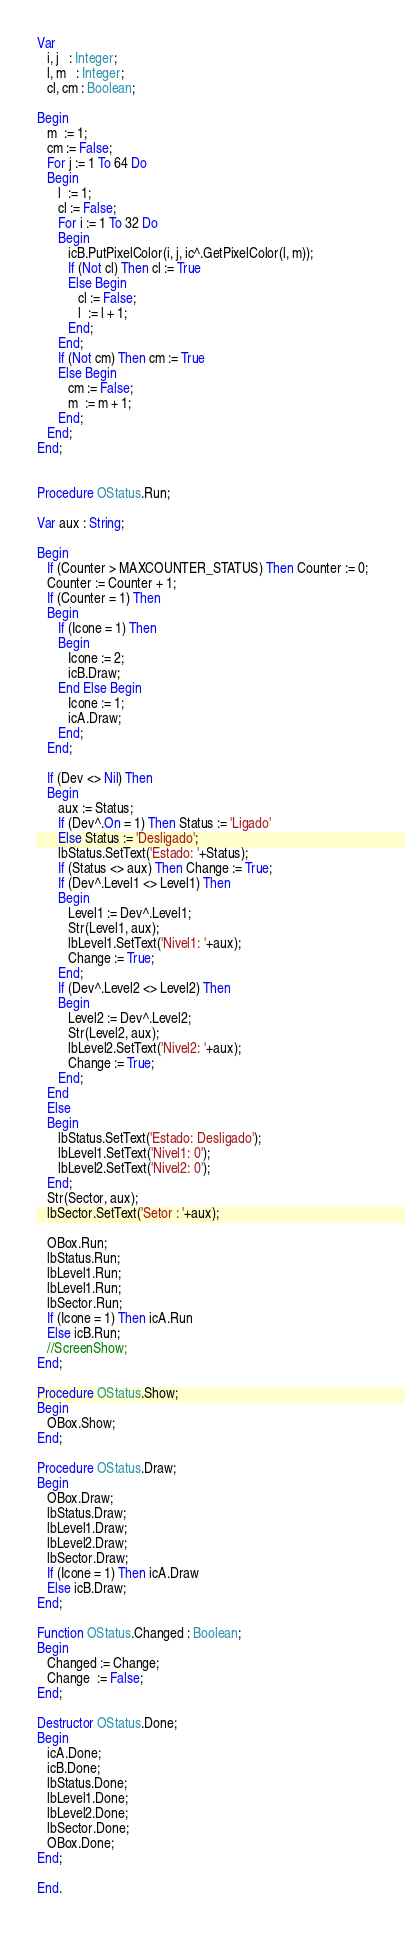<code> <loc_0><loc_0><loc_500><loc_500><_Pascal_>
Var
   i, j   : Integer;
   l, m   : Integer;
   cl, cm : Boolean;

Begin
   m  := 1;
   cm := False;
   For j := 1 To 64 Do
   Begin
      l  := 1;
      cl := False;
      For i := 1 To 32 Do
      Begin
         icB.PutPixelColor(i, j, ic^.GetPixelColor(l, m));
         If (Not cl) Then cl := True
         Else Begin
            cl := False;
            l  := l + 1;
         End;
      End;
      If (Not cm) Then cm := True
      Else Begin
         cm := False;
         m  := m + 1;
      End;
   End;
End;


Procedure OStatus.Run;

Var aux : String;

Begin
   If (Counter > MAXCOUNTER_STATUS) Then Counter := 0;
   Counter := Counter + 1;
   If (Counter = 1) Then
   Begin
      If (Icone = 1) Then
      Begin
         Icone := 2;
         icB.Draw;
      End Else Begin
         Icone := 1;
         icA.Draw;
      End;
   End;

   If (Dev <> Nil) Then
   Begin
      aux := Status;
      If (Dev^.On = 1) Then Status := 'Ligado'
      Else Status := 'Desligado';
      lbStatus.SetText('Estado: '+Status);
      If (Status <> aux) Then Change := True;
      If (Dev^.Level1 <> Level1) Then
      Begin
         Level1 := Dev^.Level1;
         Str(Level1, aux);
         lbLevel1.SetText('Nivel1: '+aux);
         Change := True;
      End;
      If (Dev^.Level2 <> Level2) Then
      Begin
         Level2 := Dev^.Level2;
         Str(Level2, aux);
         lbLevel2.SetText('Nivel2: '+aux);
         Change := True;
      End;
   End
   Else
   Begin
      lbStatus.SetText('Estado: Desligado');
      lbLevel1.SetText('Nivel1: 0');
      lbLevel2.SetText('Nivel2: 0');
   End;
   Str(Sector, aux);
   lbSector.SetText('Setor : '+aux);

   OBox.Run;
   lbStatus.Run;
   lbLevel1.Run;
   lbLevel1.Run;
   lbSector.Run;
   If (Icone = 1) Then icA.Run
   Else icB.Run;
   //ScreenShow;
End;

Procedure OStatus.Show;
Begin
   OBox.Show;
End;

Procedure OStatus.Draw;
Begin
   OBox.Draw;
   lbStatus.Draw;
   lbLevel1.Draw;
   lbLevel2.Draw;
   lbSector.Draw;
   If (Icone = 1) Then icA.Draw
   Else icB.Draw;
End;

Function OStatus.Changed : Boolean;
Begin
   Changed := Change;
   Change  := False;
End;

Destructor OStatus.Done;
Begin
   icA.Done;
   icB.Done;
   lbStatus.Done;
   lbLevel1.Done;
   lbLevel2.Done;
   lbSector.Done;
   OBox.Done;
End;

End.
</code> 